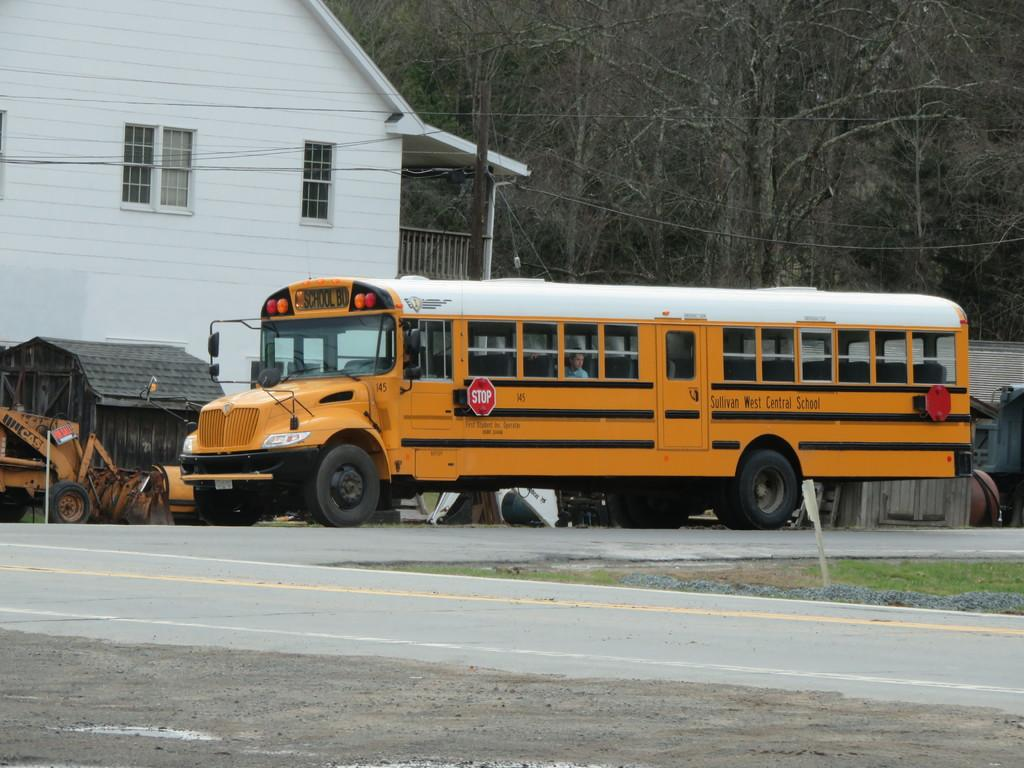What is the main subject of the image? There is a bus on the road in the image. What can be seen in the background of the image? There is a building and trees in the background of the image. Are there any other vehicles visible in the image? Yes, there is a vehicle in the background of the image. What is the metal object on the right side of the image? The metal object on the right side of the image is not specified, but it is mentioned as being present. What type of guitar can be seen hanging on the building in the image? There is no guitar present in the image; it only features a bus on the road, a building, trees, and a vehicle in the background, as well as a metal object on the right side. 